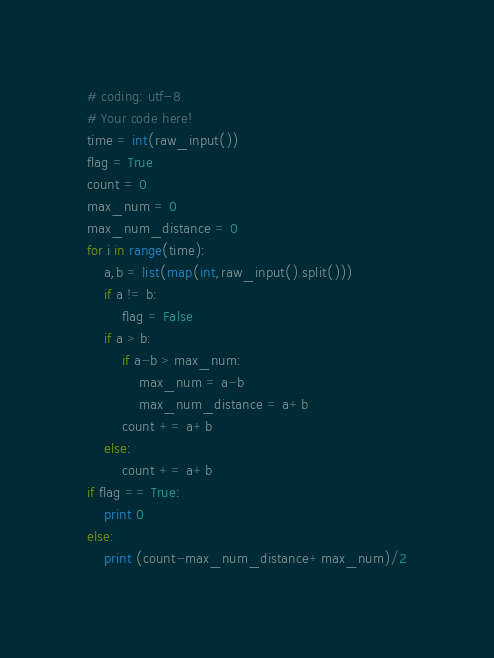<code> <loc_0><loc_0><loc_500><loc_500><_Python_># coding: utf-8
# Your code here!
time = int(raw_input())
flag = True
count = 0
max_num = 0
max_num_distance = 0
for i in range(time):
    a,b = list(map(int,raw_input().split()))
    if a != b:
        flag = False
    if a > b:
        if a-b > max_num:
            max_num = a-b
            max_num_distance = a+b
        count += a+b
    else:
        count += a+b
if flag == True:
    print 0
else:
    print (count-max_num_distance+max_num)/2</code> 